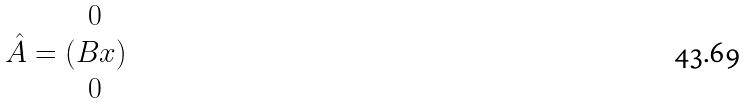Convert formula to latex. <formula><loc_0><loc_0><loc_500><loc_500>\hat { A } = ( \begin{matrix} 0 \\ B x \\ 0 \end{matrix} )</formula> 